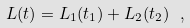<formula> <loc_0><loc_0><loc_500><loc_500>L ( t ) = L _ { 1 } ( t _ { 1 } ) + L _ { 2 } ( t _ { 2 } ) \ ,</formula> 